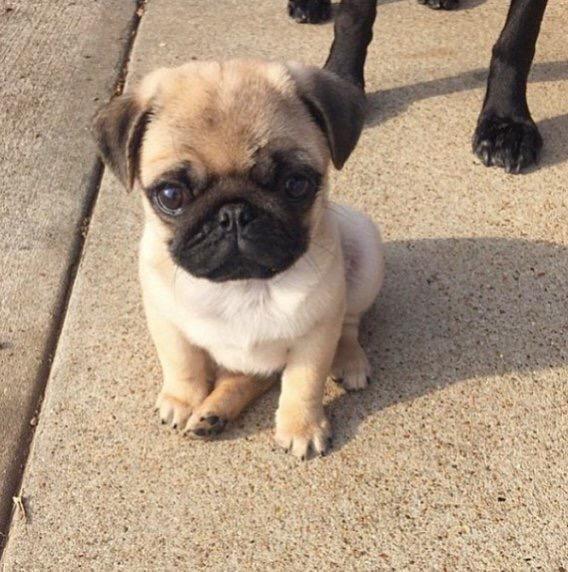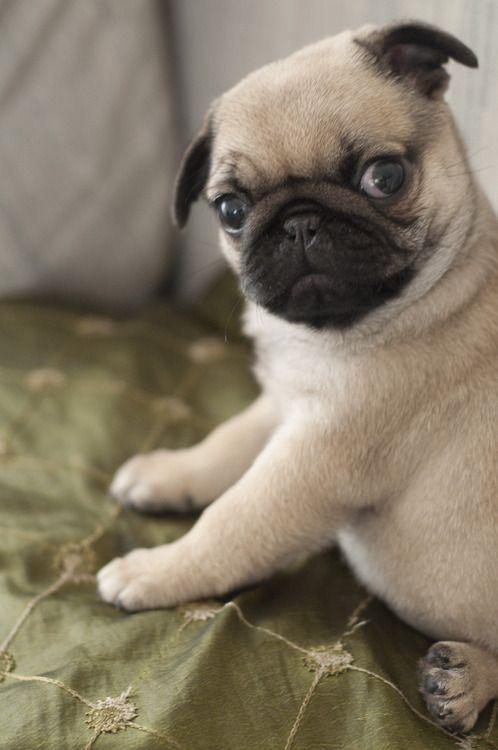The first image is the image on the left, the second image is the image on the right. Evaluate the accuracy of this statement regarding the images: "There are two puppies total.". Is it true? Answer yes or no. Yes. The first image is the image on the left, the second image is the image on the right. For the images shown, is this caption "There are two puppies" true? Answer yes or no. Yes. 